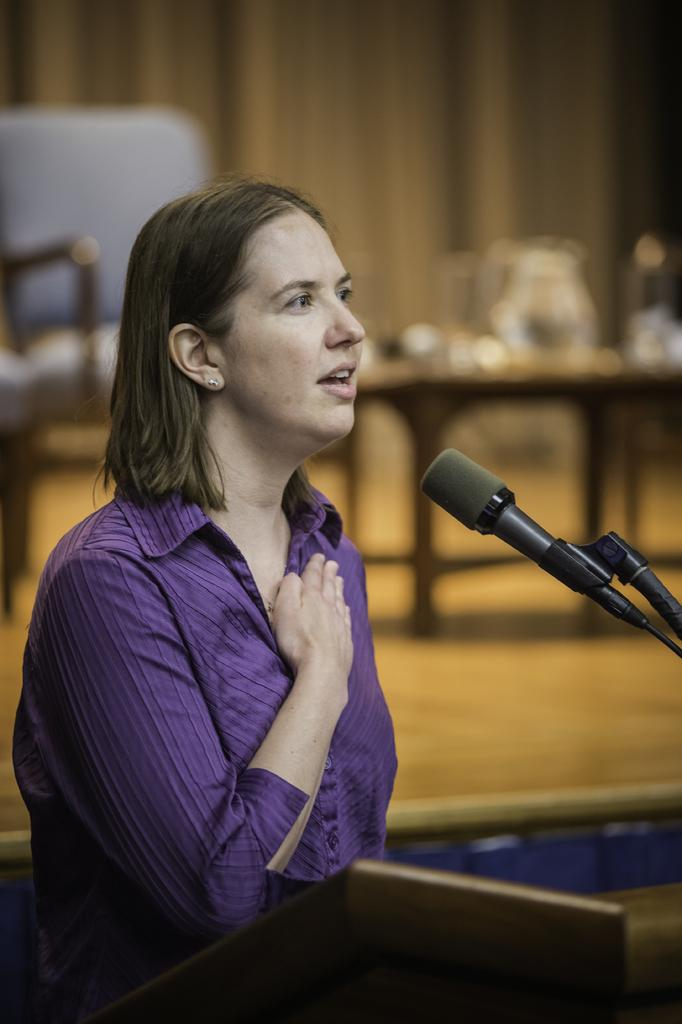What is the woman doing in the image? The woman is standing near a podium in the image. What is the purpose of the microphone in the image? The microphone is on a stand in the image, likely for the woman to use for speaking. What can be seen in the background of the image? There is a table in the background of the image. How would you describe the background of the image? The background of the image is slightly blurred. What types of pets are visible in the image? There are no pets visible in the image. What kind of machine is being used by the woman in the image? The woman is not using any machine in the image; she is standing near a podium with a microphone. 